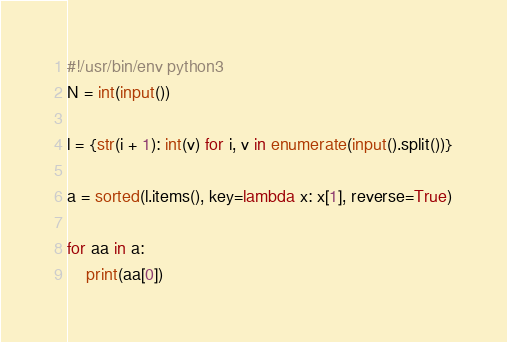<code> <loc_0><loc_0><loc_500><loc_500><_Python_>#!/usr/bin/env python3
N = int(input())

l = {str(i + 1): int(v) for i, v in enumerate(input().split())}

a = sorted(l.items(), key=lambda x: x[1], reverse=True)

for aa in a:
    print(aa[0])
</code> 